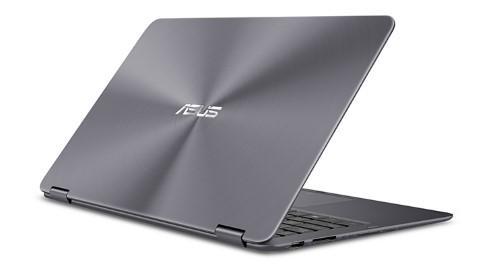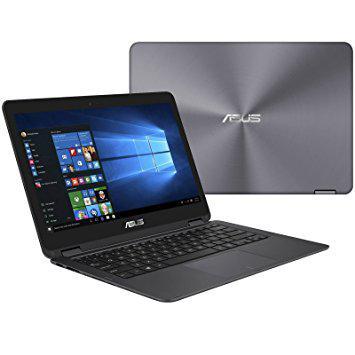The first image is the image on the left, the second image is the image on the right. Analyze the images presented: Is the assertion "You cannot see the screen of the laptop on the right side of the image." valid? Answer yes or no. No. The first image is the image on the left, the second image is the image on the right. Assess this claim about the two images: "The name on the lid and the screen can both be seen.". Correct or not? Answer yes or no. Yes. 